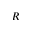<formula> <loc_0><loc_0><loc_500><loc_500>R</formula> 